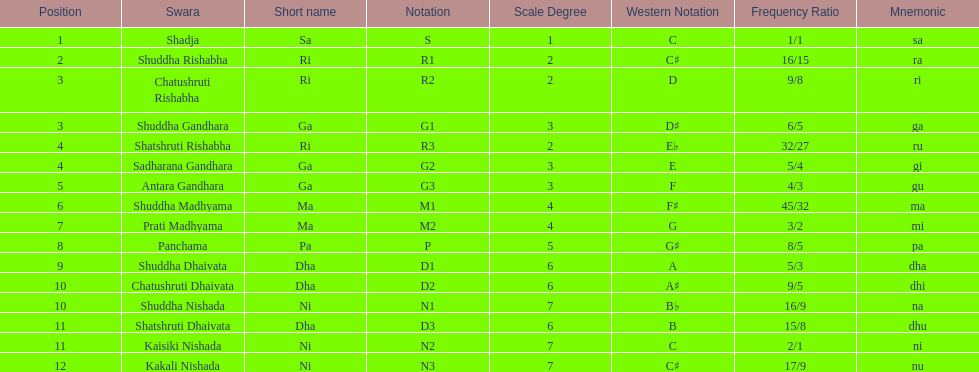What is the name of the swara that comes after panchama? Shuddha Dhaivata. 